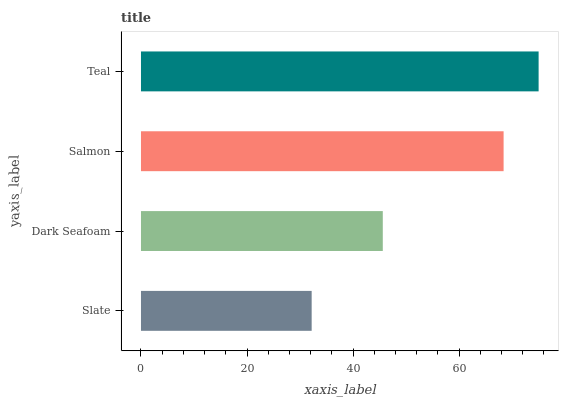Is Slate the minimum?
Answer yes or no. Yes. Is Teal the maximum?
Answer yes or no. Yes. Is Dark Seafoam the minimum?
Answer yes or no. No. Is Dark Seafoam the maximum?
Answer yes or no. No. Is Dark Seafoam greater than Slate?
Answer yes or no. Yes. Is Slate less than Dark Seafoam?
Answer yes or no. Yes. Is Slate greater than Dark Seafoam?
Answer yes or no. No. Is Dark Seafoam less than Slate?
Answer yes or no. No. Is Salmon the high median?
Answer yes or no. Yes. Is Dark Seafoam the low median?
Answer yes or no. Yes. Is Teal the high median?
Answer yes or no. No. Is Slate the low median?
Answer yes or no. No. 